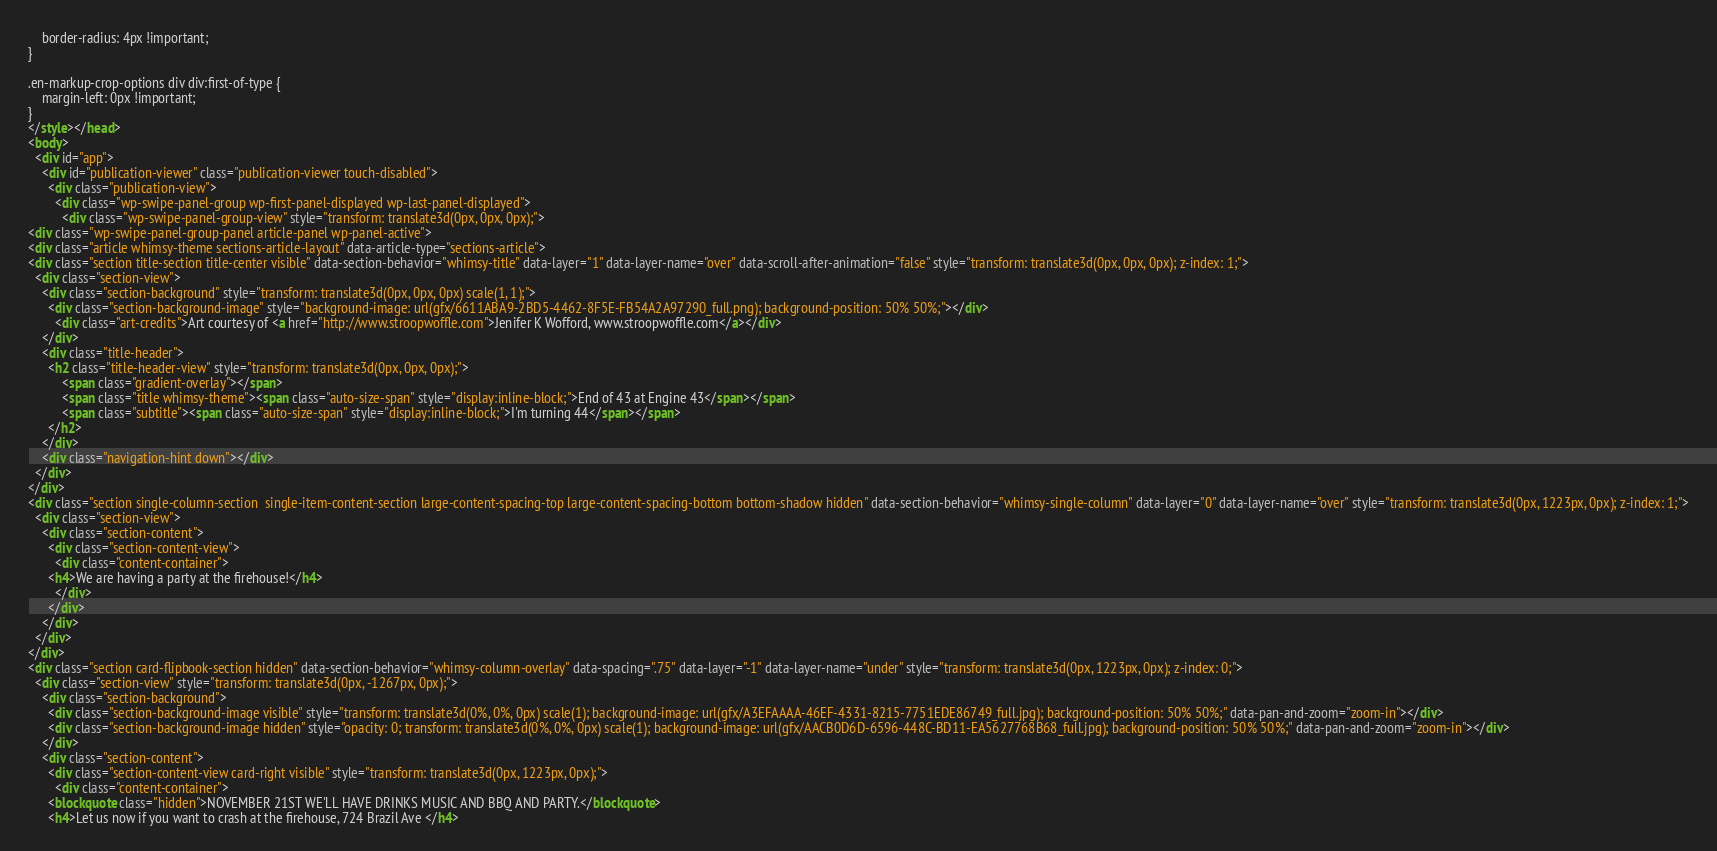Convert code to text. <code><loc_0><loc_0><loc_500><loc_500><_HTML_>    border-radius: 4px !important;
}

.en-markup-crop-options div div:first-of-type {
    margin-left: 0px !important;
}
</style></head>
<body>
  <div id="app">
    <div id="publication-viewer" class="publication-viewer touch-disabled">
      <div class="publication-view">
        <div class="wp-swipe-panel-group wp-first-panel-displayed wp-last-panel-displayed">
          <div class="wp-swipe-panel-group-view" style="transform: translate3d(0px, 0px, 0px);">
<div class="wp-swipe-panel-group-panel article-panel wp-panel-active">
<div class="article whimsy-theme sections-article-layout" data-article-type="sections-article">
<div class="section title-section title-center visible" data-section-behavior="whimsy-title" data-layer="1" data-layer-name="over" data-scroll-after-animation="false" style="transform: translate3d(0px, 0px, 0px); z-index: 1;">
  <div class="section-view">
    <div class="section-background" style="transform: translate3d(0px, 0px, 0px) scale(1, 1);">
      <div class="section-background-image" style="background-image: url(gfx/6611ABA9-2BD5-4462-8F5E-FB54A2A97290_full.png); background-position: 50% 50%;"></div>
        <div class="art-credits">Art courtesy of <a href="http://www.stroopwoffle.com">Jenifer K Wofford, www.stroopwoffle.com</a></div>
    </div>
    <div class="title-header">
      <h2 class="title-header-view" style="transform: translate3d(0px, 0px, 0px);">
          <span class="gradient-overlay"></span>
          <span class="title whimsy-theme"><span class="auto-size-span" style="display:inline-block;">End of 43 at Engine 43</span></span>
          <span class="subtitle"><span class="auto-size-span" style="display:inline-block;">I'm turning 44</span></span>
      </h2>
    </div>
    <div class="navigation-hint down"></div>
  </div>
</div>
<div class="section single-column-section  single-item-content-section large-content-spacing-top large-content-spacing-bottom bottom-shadow hidden" data-section-behavior="whimsy-single-column" data-layer="0" data-layer-name="over" style="transform: translate3d(0px, 1223px, 0px); z-index: 1;">
  <div class="section-view">
    <div class="section-content">
      <div class="section-content-view">
        <div class="content-container">
      <h4>We are having a party at the firehouse!</h4>
        </div>
      </div>
    </div>
  </div>
</div>
<div class="section card-flipbook-section hidden" data-section-behavior="whimsy-column-overlay" data-spacing=".75" data-layer="-1" data-layer-name="under" style="transform: translate3d(0px, 1223px, 0px); z-index: 0;">
  <div class="section-view" style="transform: translate3d(0px, -1267px, 0px);">
    <div class="section-background">
      <div class="section-background-image visible" style="transform: translate3d(0%, 0%, 0px) scale(1); background-image: url(gfx/A3EFAAAA-46EF-4331-8215-7751EDE86749_full.jpg); background-position: 50% 50%;" data-pan-and-zoom="zoom-in"></div>
      <div class="section-background-image hidden" style="opacity: 0; transform: translate3d(0%, 0%, 0px) scale(1); background-image: url(gfx/AACB0D6D-6596-448C-BD11-EA5627768B68_full.jpg); background-position: 50% 50%;" data-pan-and-zoom="zoom-in"></div>
    </div>
    <div class="section-content">
      <div class="section-content-view card-right visible" style="transform: translate3d(0px, 1223px, 0px);">
        <div class="content-container">
      <blockquote class="hidden">NOVEMBER 21ST WE'LL HAVE DRINKS MUSIC AND BBQ AND PARTY.</blockquote>
      <h4>Let us now if you want to crash at the firehouse, 724 Brazil Ave </h4></code> 